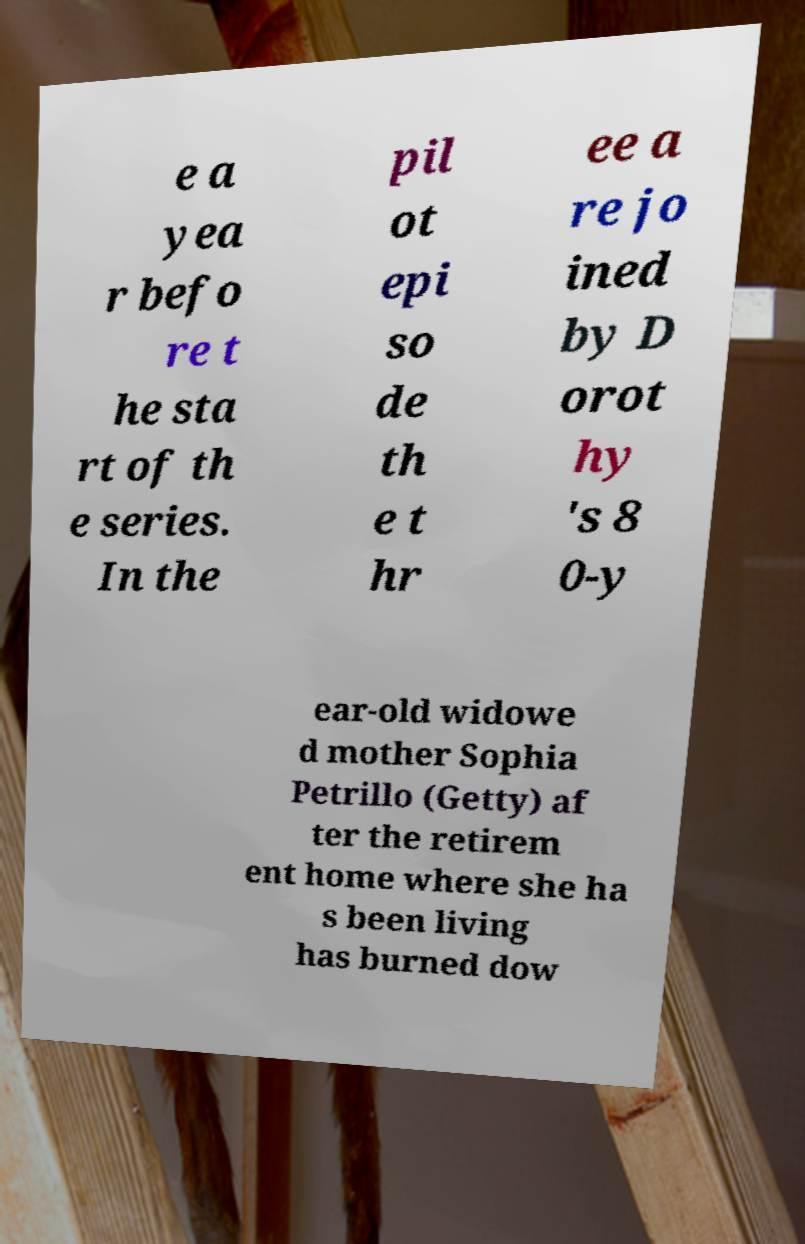Can you accurately transcribe the text from the provided image for me? e a yea r befo re t he sta rt of th e series. In the pil ot epi so de th e t hr ee a re jo ined by D orot hy 's 8 0-y ear-old widowe d mother Sophia Petrillo (Getty) af ter the retirem ent home where she ha s been living has burned dow 